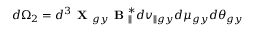<formula> <loc_0><loc_0><loc_500><loc_500>d \Omega _ { 2 } = d ^ { 3 } X _ { g y } B _ { \| } ^ { * } d v _ { \| g y } d \mu _ { g y } d \theta _ { g y }</formula> 